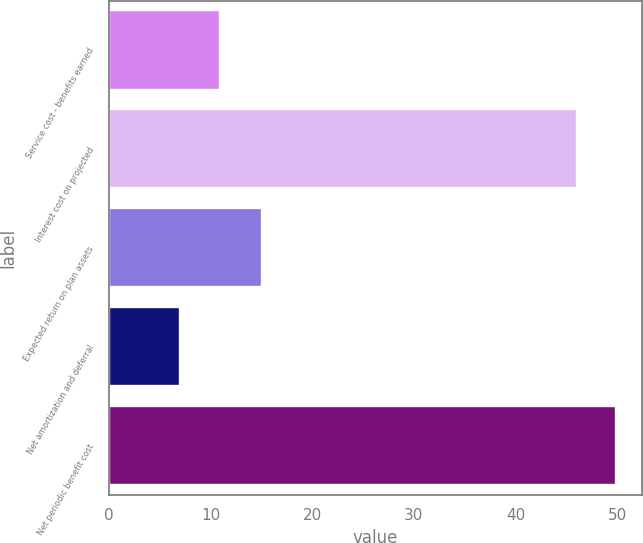Convert chart. <chart><loc_0><loc_0><loc_500><loc_500><bar_chart><fcel>Service cost - benefits earned<fcel>Interest cost on projected<fcel>Expected return on plan assets<fcel>Net amortization and deferral<fcel>Net periodic benefit cost<nl><fcel>10.9<fcel>46<fcel>15<fcel>7<fcel>49.9<nl></chart> 